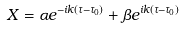Convert formula to latex. <formula><loc_0><loc_0><loc_500><loc_500>X = \alpha e ^ { - i k ( \tau - \tau _ { 0 } ) } + \beta e ^ { i k ( \tau - \tau _ { 0 } ) }</formula> 